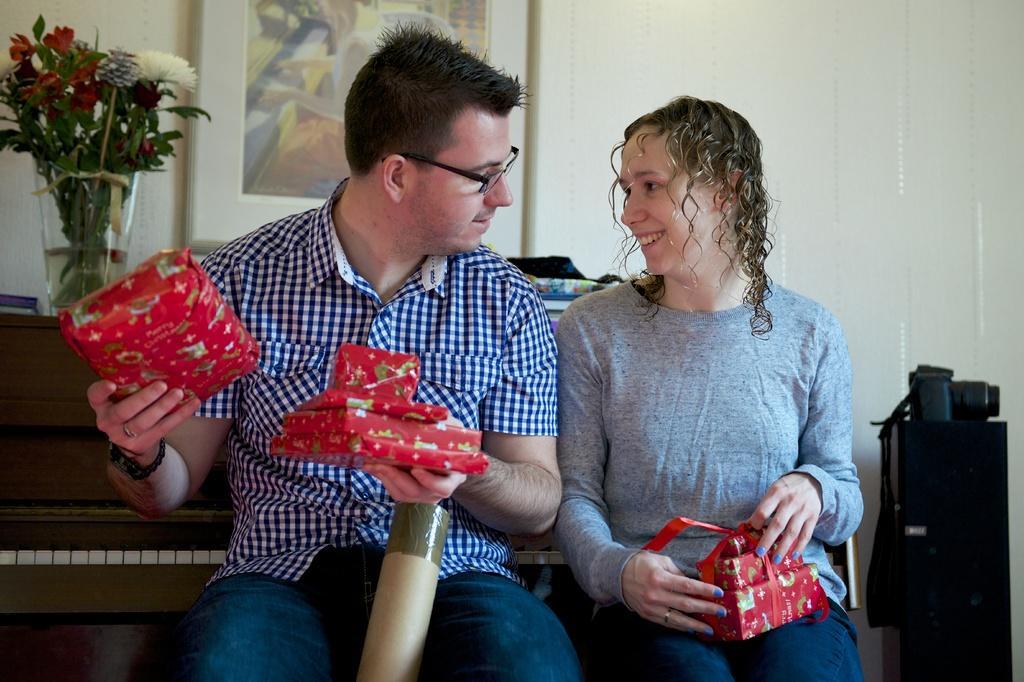Could you give a brief overview of what you see in this image? In this picture I can see there is a man, a woman. The man is having spectacles and there is a piano in the backdrop, there is a black color object and there is a camera on it. There is a flower vase on the piano and there is a door at the right side. 